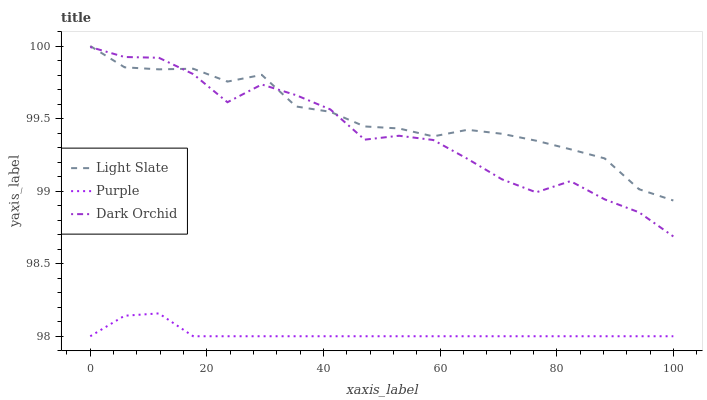Does Purple have the minimum area under the curve?
Answer yes or no. Yes. Does Light Slate have the maximum area under the curve?
Answer yes or no. Yes. Does Dark Orchid have the minimum area under the curve?
Answer yes or no. No. Does Dark Orchid have the maximum area under the curve?
Answer yes or no. No. Is Purple the smoothest?
Answer yes or no. Yes. Is Dark Orchid the roughest?
Answer yes or no. Yes. Is Dark Orchid the smoothest?
Answer yes or no. No. Is Purple the roughest?
Answer yes or no. No. Does Dark Orchid have the lowest value?
Answer yes or no. No. Does Light Slate have the highest value?
Answer yes or no. Yes. Does Dark Orchid have the highest value?
Answer yes or no. No. Is Purple less than Light Slate?
Answer yes or no. Yes. Is Dark Orchid greater than Purple?
Answer yes or no. Yes. Does Light Slate intersect Dark Orchid?
Answer yes or no. Yes. Is Light Slate less than Dark Orchid?
Answer yes or no. No. Is Light Slate greater than Dark Orchid?
Answer yes or no. No. Does Purple intersect Light Slate?
Answer yes or no. No. 